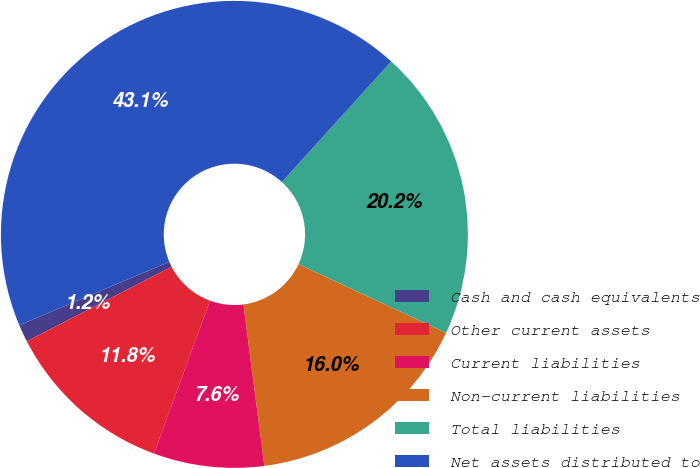Convert chart to OTSL. <chart><loc_0><loc_0><loc_500><loc_500><pie_chart><fcel>Cash and cash equivalents<fcel>Other current assets<fcel>Current liabilities<fcel>Non-current liabilities<fcel>Total liabilities<fcel>Net assets distributed to<nl><fcel>1.21%<fcel>11.83%<fcel>7.65%<fcel>16.02%<fcel>20.21%<fcel>43.08%<nl></chart> 